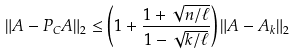<formula> <loc_0><loc_0><loc_500><loc_500>\| A - P _ { C } A \| _ { 2 } & \leq \left ( 1 + \frac { 1 + \sqrt { n / \ell } } { 1 - \sqrt { k / \ell } } \right ) \| A - A _ { k } \| _ { 2 }</formula> 